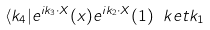<formula> <loc_0><loc_0><loc_500><loc_500>\langle k _ { 4 } | e ^ { i k _ { 3 } \cdot X } ( x ) e ^ { i k _ { 2 } \cdot X } ( 1 ) \ k e t { k _ { 1 } }</formula> 